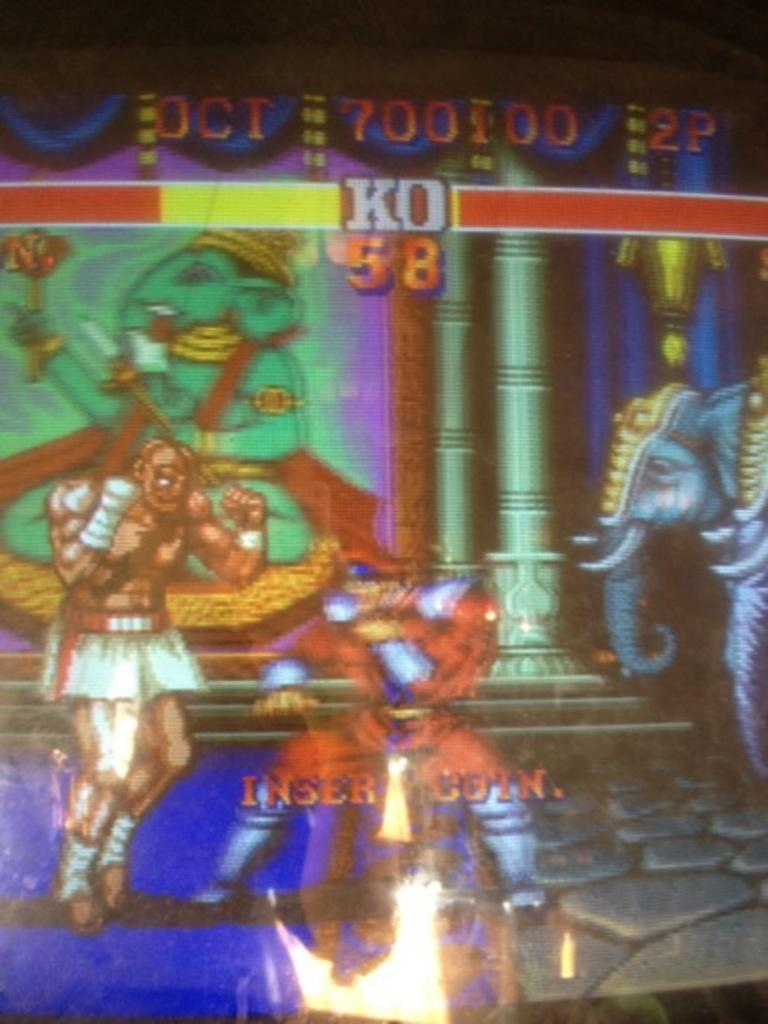What type of image is being described? The image is animated. What type of feast is being prepared in the image? There is no feast present in the image, as it is animated and not a still image of a scene. What is the head doing in the image? There is no head present in the image, as it is animated and not a still image of a scene. 